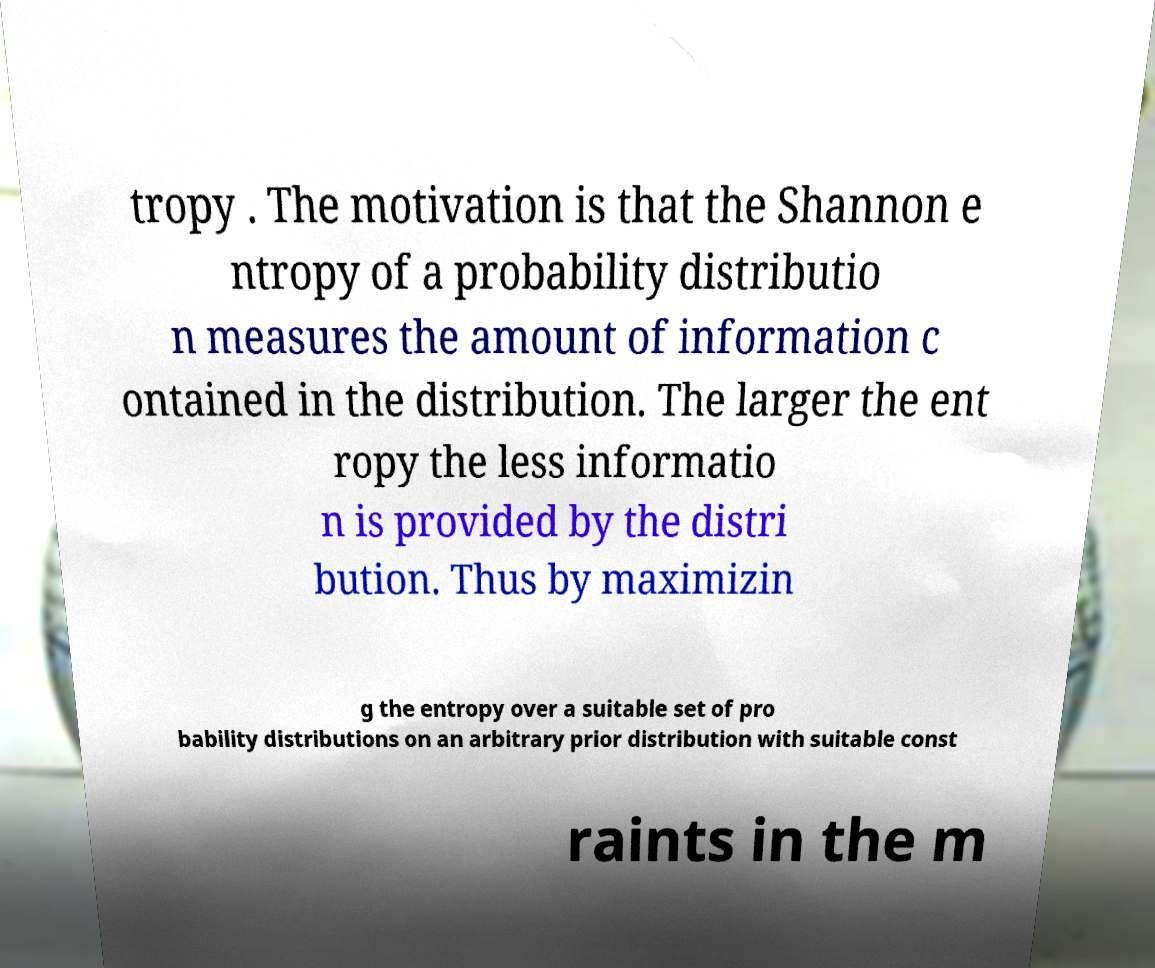Could you assist in decoding the text presented in this image and type it out clearly? tropy . The motivation is that the Shannon e ntropy of a probability distributio n measures the amount of information c ontained in the distribution. The larger the ent ropy the less informatio n is provided by the distri bution. Thus by maximizin g the entropy over a suitable set of pro bability distributions on an arbitrary prior distribution with suitable const raints in the m 